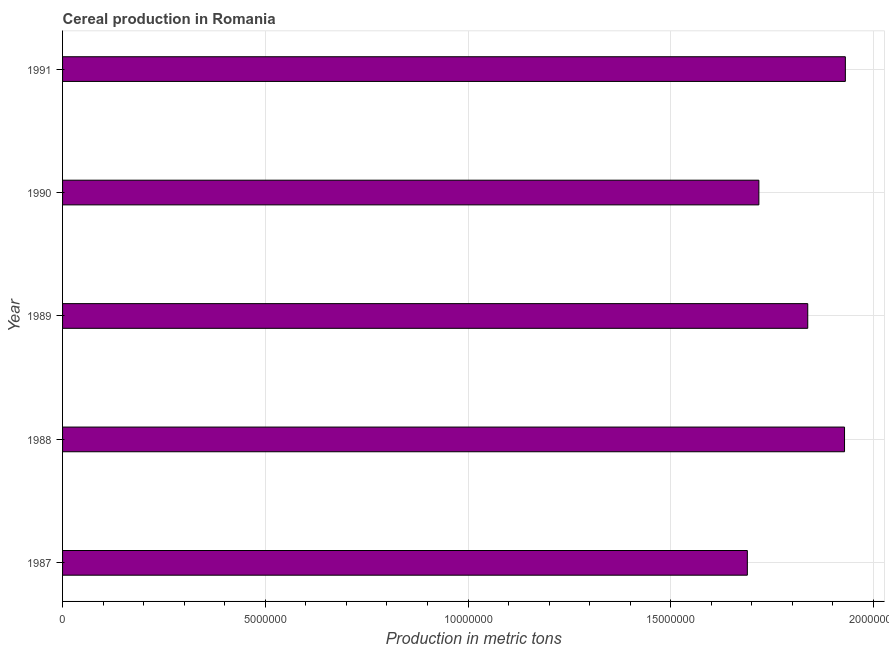Does the graph contain grids?
Your response must be concise. Yes. What is the title of the graph?
Your answer should be very brief. Cereal production in Romania. What is the label or title of the X-axis?
Provide a short and direct response. Production in metric tons. What is the cereal production in 1991?
Ensure brevity in your answer.  1.93e+07. Across all years, what is the maximum cereal production?
Your answer should be compact. 1.93e+07. Across all years, what is the minimum cereal production?
Provide a succinct answer. 1.69e+07. In which year was the cereal production maximum?
Your answer should be compact. 1991. What is the sum of the cereal production?
Your answer should be very brief. 9.10e+07. What is the difference between the cereal production in 1989 and 1991?
Offer a very short reply. -9.28e+05. What is the average cereal production per year?
Offer a terse response. 1.82e+07. What is the median cereal production?
Provide a succinct answer. 1.84e+07. In how many years, is the cereal production greater than 8000000 metric tons?
Provide a short and direct response. 5. What is the ratio of the cereal production in 1990 to that in 1991?
Give a very brief answer. 0.89. Is the cereal production in 1988 less than that in 1991?
Offer a very short reply. Yes. Is the difference between the cereal production in 1989 and 1990 greater than the difference between any two years?
Your response must be concise. No. What is the difference between the highest and the second highest cereal production?
Give a very brief answer. 2.02e+04. What is the difference between the highest and the lowest cereal production?
Your response must be concise. 2.42e+06. In how many years, is the cereal production greater than the average cereal production taken over all years?
Your answer should be compact. 3. How many bars are there?
Make the answer very short. 5. How many years are there in the graph?
Offer a very short reply. 5. What is the difference between two consecutive major ticks on the X-axis?
Offer a terse response. 5.00e+06. Are the values on the major ticks of X-axis written in scientific E-notation?
Your answer should be very brief. No. What is the Production in metric tons of 1987?
Ensure brevity in your answer.  1.69e+07. What is the Production in metric tons in 1988?
Provide a succinct answer. 1.93e+07. What is the Production in metric tons of 1989?
Give a very brief answer. 1.84e+07. What is the Production in metric tons in 1990?
Give a very brief answer. 1.72e+07. What is the Production in metric tons of 1991?
Your answer should be very brief. 1.93e+07. What is the difference between the Production in metric tons in 1987 and 1988?
Provide a short and direct response. -2.40e+06. What is the difference between the Production in metric tons in 1987 and 1989?
Keep it short and to the point. -1.49e+06. What is the difference between the Production in metric tons in 1987 and 1990?
Provide a succinct answer. -2.84e+05. What is the difference between the Production in metric tons in 1987 and 1991?
Your answer should be compact. -2.42e+06. What is the difference between the Production in metric tons in 1988 and 1989?
Provide a succinct answer. 9.07e+05. What is the difference between the Production in metric tons in 1988 and 1990?
Ensure brevity in your answer.  2.11e+06. What is the difference between the Production in metric tons in 1988 and 1991?
Your answer should be compact. -2.02e+04. What is the difference between the Production in metric tons in 1989 and 1990?
Offer a terse response. 1.21e+06. What is the difference between the Production in metric tons in 1989 and 1991?
Keep it short and to the point. -9.28e+05. What is the difference between the Production in metric tons in 1990 and 1991?
Ensure brevity in your answer.  -2.13e+06. What is the ratio of the Production in metric tons in 1987 to that in 1988?
Keep it short and to the point. 0.88. What is the ratio of the Production in metric tons in 1987 to that in 1989?
Give a very brief answer. 0.92. What is the ratio of the Production in metric tons in 1987 to that in 1990?
Ensure brevity in your answer.  0.98. What is the ratio of the Production in metric tons in 1988 to that in 1989?
Your answer should be compact. 1.05. What is the ratio of the Production in metric tons in 1988 to that in 1990?
Offer a very short reply. 1.12. What is the ratio of the Production in metric tons in 1988 to that in 1991?
Offer a very short reply. 1. What is the ratio of the Production in metric tons in 1989 to that in 1990?
Your answer should be very brief. 1.07. What is the ratio of the Production in metric tons in 1989 to that in 1991?
Your response must be concise. 0.95. What is the ratio of the Production in metric tons in 1990 to that in 1991?
Give a very brief answer. 0.89. 